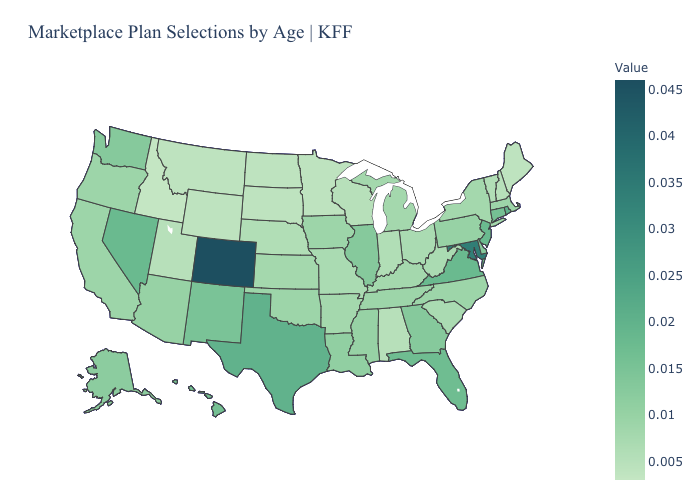Does Colorado have the highest value in the USA?
Quick response, please. Yes. Which states hav the highest value in the South?
Answer briefly. Maryland. Does Mississippi have a lower value than Montana?
Give a very brief answer. No. Among the states that border New Jersey , does Pennsylvania have the lowest value?
Be succinct. No. Does Illinois have a lower value than Texas?
Concise answer only. Yes. Does Nevada have a lower value than Alabama?
Give a very brief answer. No. Among the states that border California , which have the lowest value?
Be succinct. Oregon. Which states have the lowest value in the MidWest?
Quick response, please. Minnesota, North Dakota, South Dakota. Among the states that border Iowa , which have the lowest value?
Write a very short answer. Minnesota, South Dakota. Does Utah have the lowest value in the USA?
Be succinct. No. 